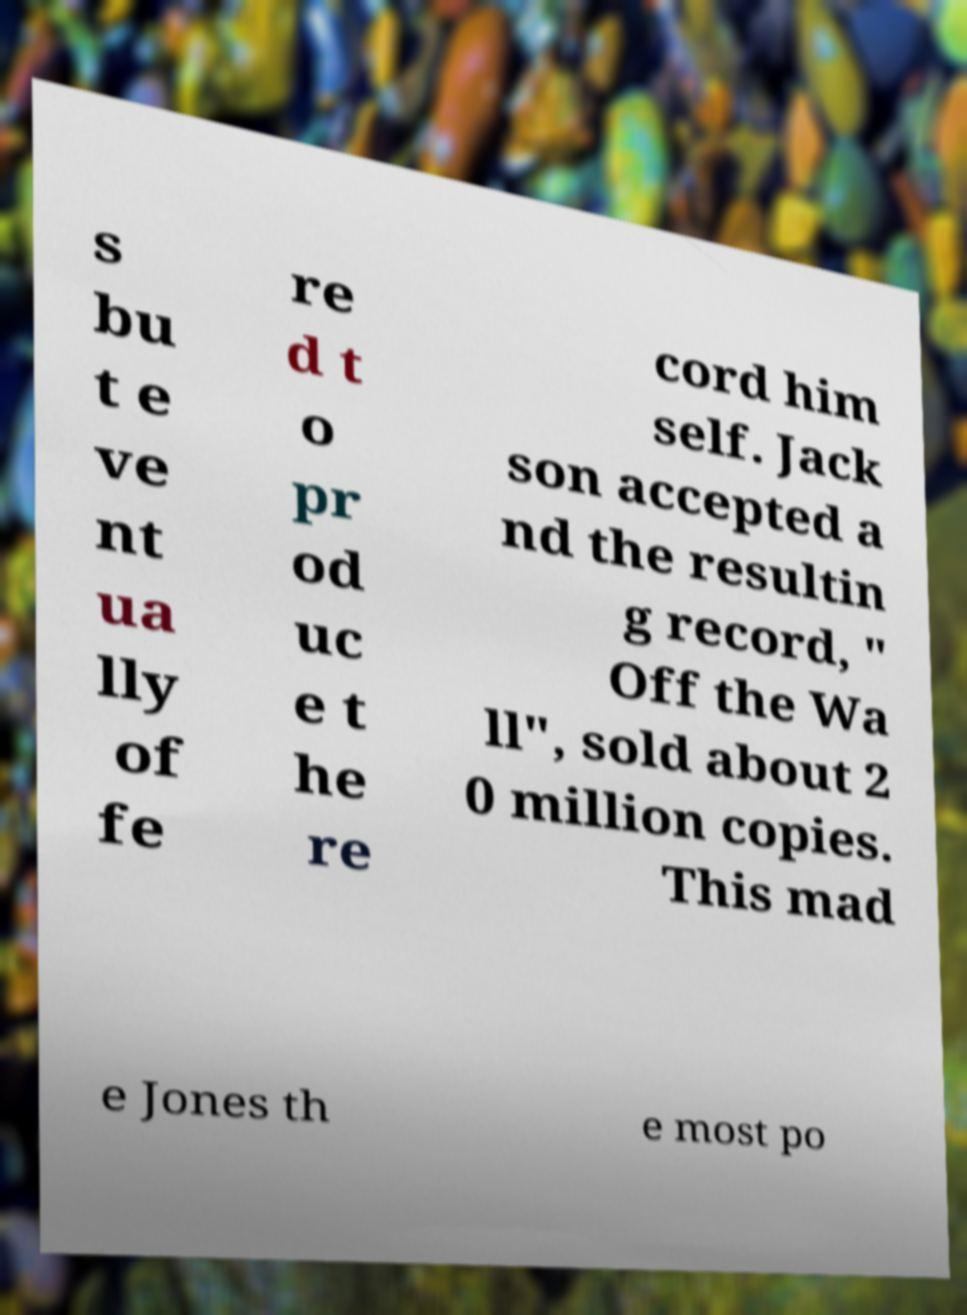Can you read and provide the text displayed in the image?This photo seems to have some interesting text. Can you extract and type it out for me? s bu t e ve nt ua lly of fe re d t o pr od uc e t he re cord him self. Jack son accepted a nd the resultin g record, " Off the Wa ll", sold about 2 0 million copies. This mad e Jones th e most po 